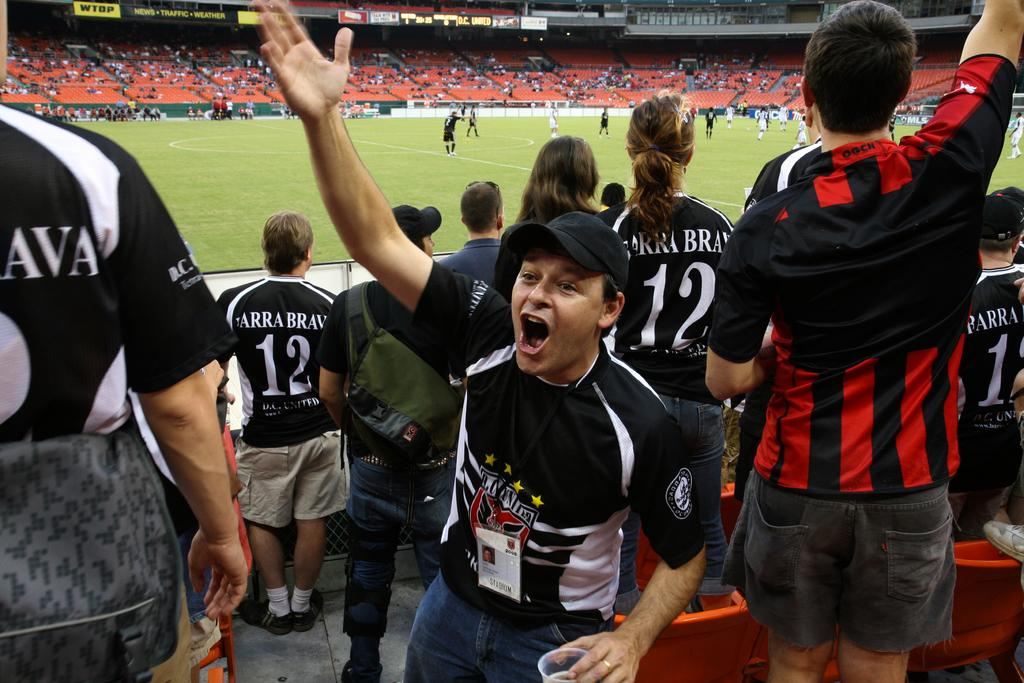<image>
Share a concise interpretation of the image provided. A sports team cheering in the stands wearing black and white shirts with BRAVA on them. 